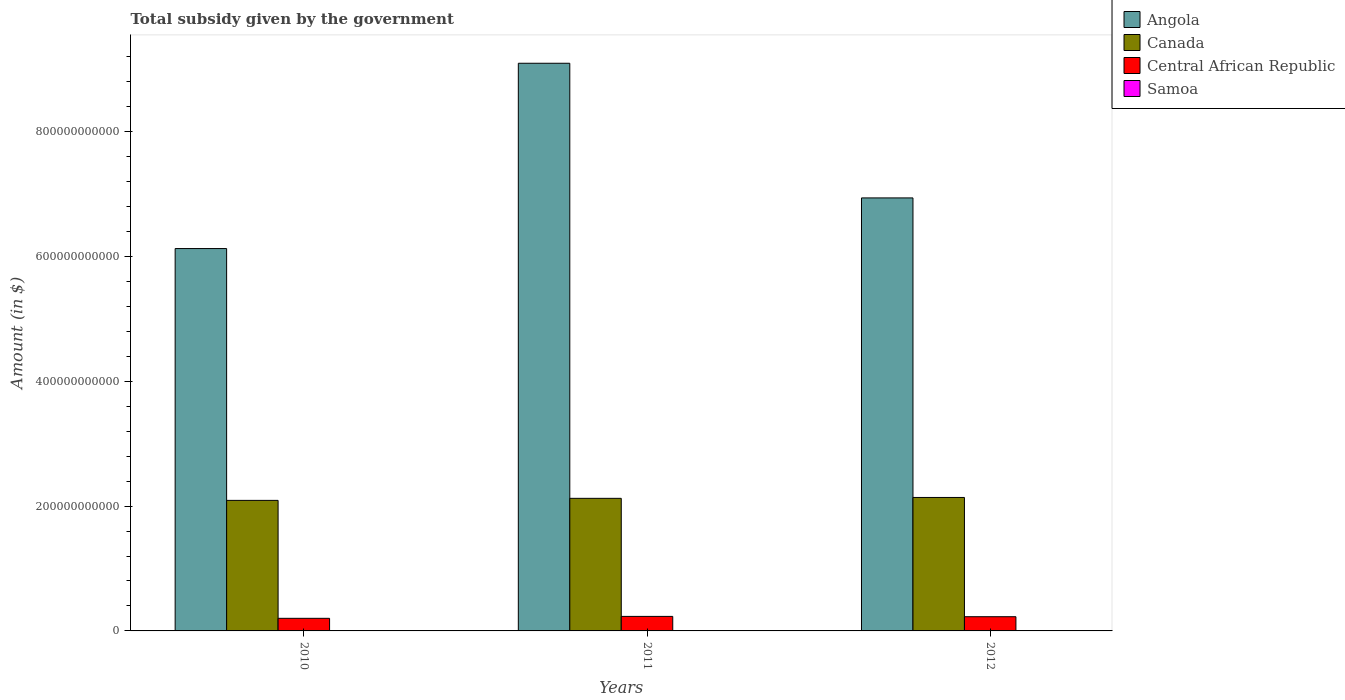How many groups of bars are there?
Keep it short and to the point. 3. Are the number of bars per tick equal to the number of legend labels?
Make the answer very short. Yes. How many bars are there on the 3rd tick from the left?
Provide a succinct answer. 4. What is the label of the 2nd group of bars from the left?
Keep it short and to the point. 2011. In how many cases, is the number of bars for a given year not equal to the number of legend labels?
Offer a very short reply. 0. What is the total revenue collected by the government in Samoa in 2012?
Ensure brevity in your answer.  1.76e+05. Across all years, what is the maximum total revenue collected by the government in Angola?
Keep it short and to the point. 9.10e+11. Across all years, what is the minimum total revenue collected by the government in Angola?
Offer a very short reply. 6.13e+11. What is the total total revenue collected by the government in Central African Republic in the graph?
Offer a very short reply. 6.62e+1. What is the difference between the total revenue collected by the government in Central African Republic in 2011 and that in 2012?
Your answer should be compact. 5.22e+08. What is the difference between the total revenue collected by the government in Central African Republic in 2011 and the total revenue collected by the government in Samoa in 2012?
Offer a terse response. 2.33e+1. What is the average total revenue collected by the government in Angola per year?
Your answer should be very brief. 7.39e+11. In the year 2012, what is the difference between the total revenue collected by the government in Angola and total revenue collected by the government in Samoa?
Provide a short and direct response. 6.94e+11. What is the ratio of the total revenue collected by the government in Angola in 2010 to that in 2012?
Your answer should be compact. 0.88. Is the difference between the total revenue collected by the government in Angola in 2010 and 2012 greater than the difference between the total revenue collected by the government in Samoa in 2010 and 2012?
Your answer should be compact. No. What is the difference between the highest and the second highest total revenue collected by the government in Samoa?
Your answer should be very brief. 4748.99. What is the difference between the highest and the lowest total revenue collected by the government in Central African Republic?
Your response must be concise. 3.10e+09. In how many years, is the total revenue collected by the government in Canada greater than the average total revenue collected by the government in Canada taken over all years?
Make the answer very short. 2. Is the sum of the total revenue collected by the government in Samoa in 2010 and 2012 greater than the maximum total revenue collected by the government in Central African Republic across all years?
Ensure brevity in your answer.  No. What does the 2nd bar from the left in 2011 represents?
Your answer should be very brief. Canada. What does the 1st bar from the right in 2012 represents?
Provide a short and direct response. Samoa. How many bars are there?
Provide a succinct answer. 12. Are all the bars in the graph horizontal?
Your answer should be compact. No. What is the difference between two consecutive major ticks on the Y-axis?
Make the answer very short. 2.00e+11. Where does the legend appear in the graph?
Provide a short and direct response. Top right. How are the legend labels stacked?
Keep it short and to the point. Vertical. What is the title of the graph?
Provide a succinct answer. Total subsidy given by the government. What is the label or title of the Y-axis?
Make the answer very short. Amount (in $). What is the Amount (in $) of Angola in 2010?
Give a very brief answer. 6.13e+11. What is the Amount (in $) in Canada in 2010?
Offer a very short reply. 2.09e+11. What is the Amount (in $) of Central African Republic in 2010?
Your answer should be compact. 2.02e+1. What is the Amount (in $) of Samoa in 2010?
Offer a very short reply. 1.88e+05. What is the Amount (in $) in Angola in 2011?
Keep it short and to the point. 9.10e+11. What is the Amount (in $) in Canada in 2011?
Offer a terse response. 2.12e+11. What is the Amount (in $) of Central African Republic in 2011?
Your response must be concise. 2.33e+1. What is the Amount (in $) in Samoa in 2011?
Ensure brevity in your answer.  1.84e+05. What is the Amount (in $) in Angola in 2012?
Your answer should be compact. 6.94e+11. What is the Amount (in $) of Canada in 2012?
Provide a short and direct response. 2.14e+11. What is the Amount (in $) of Central African Republic in 2012?
Give a very brief answer. 2.28e+1. What is the Amount (in $) in Samoa in 2012?
Give a very brief answer. 1.76e+05. Across all years, what is the maximum Amount (in $) of Angola?
Provide a succinct answer. 9.10e+11. Across all years, what is the maximum Amount (in $) in Canada?
Keep it short and to the point. 2.14e+11. Across all years, what is the maximum Amount (in $) of Central African Republic?
Give a very brief answer. 2.33e+1. Across all years, what is the maximum Amount (in $) of Samoa?
Keep it short and to the point. 1.88e+05. Across all years, what is the minimum Amount (in $) of Angola?
Keep it short and to the point. 6.13e+11. Across all years, what is the minimum Amount (in $) of Canada?
Provide a succinct answer. 2.09e+11. Across all years, what is the minimum Amount (in $) in Central African Republic?
Provide a succinct answer. 2.02e+1. Across all years, what is the minimum Amount (in $) in Samoa?
Offer a terse response. 1.76e+05. What is the total Amount (in $) in Angola in the graph?
Make the answer very short. 2.22e+12. What is the total Amount (in $) of Canada in the graph?
Provide a succinct answer. 6.35e+11. What is the total Amount (in $) in Central African Republic in the graph?
Ensure brevity in your answer.  6.62e+1. What is the total Amount (in $) in Samoa in the graph?
Provide a succinct answer. 5.48e+05. What is the difference between the Amount (in $) in Angola in 2010 and that in 2011?
Your answer should be compact. -2.97e+11. What is the difference between the Amount (in $) in Canada in 2010 and that in 2011?
Make the answer very short. -3.27e+09. What is the difference between the Amount (in $) in Central African Republic in 2010 and that in 2011?
Your answer should be compact. -3.10e+09. What is the difference between the Amount (in $) of Samoa in 2010 and that in 2011?
Offer a terse response. 4748.99. What is the difference between the Amount (in $) of Angola in 2010 and that in 2012?
Offer a terse response. -8.11e+1. What is the difference between the Amount (in $) of Canada in 2010 and that in 2012?
Provide a short and direct response. -4.68e+09. What is the difference between the Amount (in $) of Central African Republic in 2010 and that in 2012?
Offer a terse response. -2.58e+09. What is the difference between the Amount (in $) in Samoa in 2010 and that in 2012?
Your answer should be compact. 1.25e+04. What is the difference between the Amount (in $) of Angola in 2011 and that in 2012?
Provide a succinct answer. 2.16e+11. What is the difference between the Amount (in $) of Canada in 2011 and that in 2012?
Give a very brief answer. -1.41e+09. What is the difference between the Amount (in $) of Central African Republic in 2011 and that in 2012?
Your response must be concise. 5.22e+08. What is the difference between the Amount (in $) in Samoa in 2011 and that in 2012?
Keep it short and to the point. 7706.28. What is the difference between the Amount (in $) in Angola in 2010 and the Amount (in $) in Canada in 2011?
Offer a very short reply. 4.00e+11. What is the difference between the Amount (in $) in Angola in 2010 and the Amount (in $) in Central African Republic in 2011?
Your answer should be very brief. 5.89e+11. What is the difference between the Amount (in $) of Angola in 2010 and the Amount (in $) of Samoa in 2011?
Offer a very short reply. 6.13e+11. What is the difference between the Amount (in $) in Canada in 2010 and the Amount (in $) in Central African Republic in 2011?
Provide a succinct answer. 1.86e+11. What is the difference between the Amount (in $) of Canada in 2010 and the Amount (in $) of Samoa in 2011?
Provide a succinct answer. 2.09e+11. What is the difference between the Amount (in $) of Central African Republic in 2010 and the Amount (in $) of Samoa in 2011?
Ensure brevity in your answer.  2.02e+1. What is the difference between the Amount (in $) in Angola in 2010 and the Amount (in $) in Canada in 2012?
Keep it short and to the point. 3.99e+11. What is the difference between the Amount (in $) of Angola in 2010 and the Amount (in $) of Central African Republic in 2012?
Offer a very short reply. 5.90e+11. What is the difference between the Amount (in $) in Angola in 2010 and the Amount (in $) in Samoa in 2012?
Make the answer very short. 6.13e+11. What is the difference between the Amount (in $) in Canada in 2010 and the Amount (in $) in Central African Republic in 2012?
Offer a very short reply. 1.86e+11. What is the difference between the Amount (in $) of Canada in 2010 and the Amount (in $) of Samoa in 2012?
Offer a very short reply. 2.09e+11. What is the difference between the Amount (in $) in Central African Republic in 2010 and the Amount (in $) in Samoa in 2012?
Your response must be concise. 2.02e+1. What is the difference between the Amount (in $) in Angola in 2011 and the Amount (in $) in Canada in 2012?
Keep it short and to the point. 6.96e+11. What is the difference between the Amount (in $) in Angola in 2011 and the Amount (in $) in Central African Republic in 2012?
Offer a very short reply. 8.87e+11. What is the difference between the Amount (in $) of Angola in 2011 and the Amount (in $) of Samoa in 2012?
Your response must be concise. 9.10e+11. What is the difference between the Amount (in $) of Canada in 2011 and the Amount (in $) of Central African Republic in 2012?
Make the answer very short. 1.90e+11. What is the difference between the Amount (in $) of Canada in 2011 and the Amount (in $) of Samoa in 2012?
Your answer should be compact. 2.12e+11. What is the difference between the Amount (in $) in Central African Republic in 2011 and the Amount (in $) in Samoa in 2012?
Make the answer very short. 2.33e+1. What is the average Amount (in $) of Angola per year?
Your response must be concise. 7.39e+11. What is the average Amount (in $) of Canada per year?
Offer a very short reply. 2.12e+11. What is the average Amount (in $) in Central African Republic per year?
Ensure brevity in your answer.  2.21e+1. What is the average Amount (in $) in Samoa per year?
Provide a succinct answer. 1.83e+05. In the year 2010, what is the difference between the Amount (in $) in Angola and Amount (in $) in Canada?
Your response must be concise. 4.04e+11. In the year 2010, what is the difference between the Amount (in $) in Angola and Amount (in $) in Central African Republic?
Provide a short and direct response. 5.93e+11. In the year 2010, what is the difference between the Amount (in $) of Angola and Amount (in $) of Samoa?
Your answer should be compact. 6.13e+11. In the year 2010, what is the difference between the Amount (in $) in Canada and Amount (in $) in Central African Republic?
Your answer should be compact. 1.89e+11. In the year 2010, what is the difference between the Amount (in $) of Canada and Amount (in $) of Samoa?
Ensure brevity in your answer.  2.09e+11. In the year 2010, what is the difference between the Amount (in $) in Central African Republic and Amount (in $) in Samoa?
Your answer should be compact. 2.02e+1. In the year 2011, what is the difference between the Amount (in $) of Angola and Amount (in $) of Canada?
Your response must be concise. 6.97e+11. In the year 2011, what is the difference between the Amount (in $) of Angola and Amount (in $) of Central African Republic?
Offer a terse response. 8.86e+11. In the year 2011, what is the difference between the Amount (in $) of Angola and Amount (in $) of Samoa?
Provide a succinct answer. 9.10e+11. In the year 2011, what is the difference between the Amount (in $) of Canada and Amount (in $) of Central African Republic?
Ensure brevity in your answer.  1.89e+11. In the year 2011, what is the difference between the Amount (in $) of Canada and Amount (in $) of Samoa?
Your answer should be compact. 2.12e+11. In the year 2011, what is the difference between the Amount (in $) of Central African Republic and Amount (in $) of Samoa?
Give a very brief answer. 2.33e+1. In the year 2012, what is the difference between the Amount (in $) in Angola and Amount (in $) in Canada?
Provide a short and direct response. 4.80e+11. In the year 2012, what is the difference between the Amount (in $) in Angola and Amount (in $) in Central African Republic?
Ensure brevity in your answer.  6.71e+11. In the year 2012, what is the difference between the Amount (in $) of Angola and Amount (in $) of Samoa?
Keep it short and to the point. 6.94e+11. In the year 2012, what is the difference between the Amount (in $) of Canada and Amount (in $) of Central African Republic?
Ensure brevity in your answer.  1.91e+11. In the year 2012, what is the difference between the Amount (in $) of Canada and Amount (in $) of Samoa?
Your response must be concise. 2.14e+11. In the year 2012, what is the difference between the Amount (in $) in Central African Republic and Amount (in $) in Samoa?
Offer a terse response. 2.28e+1. What is the ratio of the Amount (in $) in Angola in 2010 to that in 2011?
Your answer should be compact. 0.67. What is the ratio of the Amount (in $) of Canada in 2010 to that in 2011?
Offer a very short reply. 0.98. What is the ratio of the Amount (in $) in Central African Republic in 2010 to that in 2011?
Provide a short and direct response. 0.87. What is the ratio of the Amount (in $) of Samoa in 2010 to that in 2011?
Keep it short and to the point. 1.03. What is the ratio of the Amount (in $) of Angola in 2010 to that in 2012?
Your answer should be compact. 0.88. What is the ratio of the Amount (in $) in Canada in 2010 to that in 2012?
Your answer should be compact. 0.98. What is the ratio of the Amount (in $) in Central African Republic in 2010 to that in 2012?
Your response must be concise. 0.89. What is the ratio of the Amount (in $) in Samoa in 2010 to that in 2012?
Ensure brevity in your answer.  1.07. What is the ratio of the Amount (in $) of Angola in 2011 to that in 2012?
Give a very brief answer. 1.31. What is the ratio of the Amount (in $) of Canada in 2011 to that in 2012?
Make the answer very short. 0.99. What is the ratio of the Amount (in $) of Central African Republic in 2011 to that in 2012?
Ensure brevity in your answer.  1.02. What is the ratio of the Amount (in $) in Samoa in 2011 to that in 2012?
Keep it short and to the point. 1.04. What is the difference between the highest and the second highest Amount (in $) of Angola?
Offer a very short reply. 2.16e+11. What is the difference between the highest and the second highest Amount (in $) of Canada?
Make the answer very short. 1.41e+09. What is the difference between the highest and the second highest Amount (in $) of Central African Republic?
Make the answer very short. 5.22e+08. What is the difference between the highest and the second highest Amount (in $) in Samoa?
Offer a very short reply. 4748.99. What is the difference between the highest and the lowest Amount (in $) of Angola?
Provide a succinct answer. 2.97e+11. What is the difference between the highest and the lowest Amount (in $) of Canada?
Give a very brief answer. 4.68e+09. What is the difference between the highest and the lowest Amount (in $) in Central African Republic?
Offer a terse response. 3.10e+09. What is the difference between the highest and the lowest Amount (in $) of Samoa?
Give a very brief answer. 1.25e+04. 